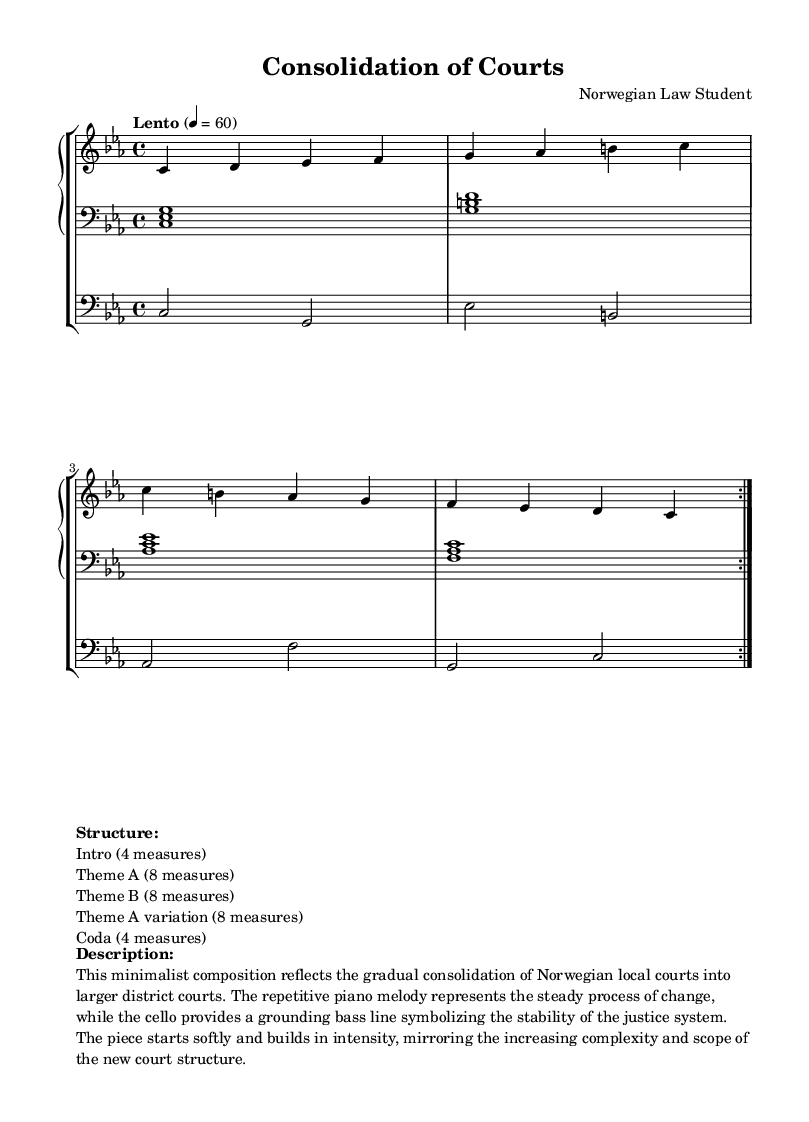What is the key signature of this music? The key signature is C minor, which has three flats (B flat, E flat, and A flat). It can be confirmed by looking at the key signature indicated at the beginning of the staff.
Answer: C minor What is the time signature used in this piece? The time signature shown at the beginning of the score is 4/4, which means there are four beats in each measure, and each beat is represented by a quarter note. This is visually identifiable in the notational context.
Answer: 4/4 What is the tempo marking for this composition? The tempo marking is "Lento," which indicates a slow tempo, typically around 40 to 60 beats per minute. This is reflected in the tempo indication at the start of the score.
Answer: Lento How many measures are in Theme A? Theme A is composed of 8 measures, as indicated by its notation section, which specifies that it follows the introductory section. Each repeated segment has 8 measures shown in the structure.
Answer: 8 measures What does the cello represent in this composition? The cello part serves to provide a grounding bass line symbolizing the stability of the justice system. This interpretation can be deduced from the description included in the score’s markup, which connects the cello’s role to the overarching theme.
Answer: Stability How does the structure progress throughout the piece? The structure progresses from Intro to Theme A, Theme B, Theme A variation, and then Coda, which can be determined by examining the markup that outlines the order of sections in the piece.
Answer: Intro, Theme A, Theme B, Theme A variation, Coda What does the repetitive melody signify in the context of the composition? The repetitive piano melody represents the steady process of change, as stated in the provided description of the piece. This reflects the minimalist style, which often emphasizes repetition to create a sense of gradual transformation.
Answer: Steady process of change 